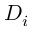Convert formula to latex. <formula><loc_0><loc_0><loc_500><loc_500>D _ { i }</formula> 